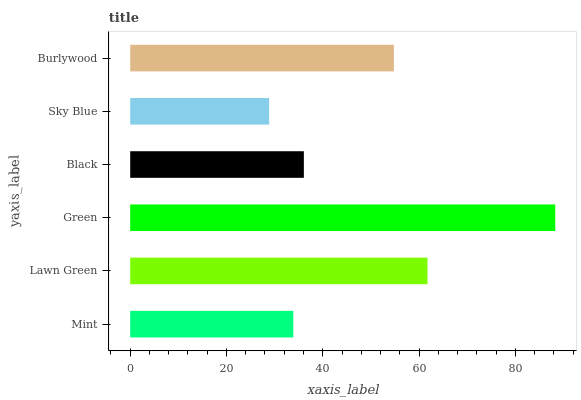Is Sky Blue the minimum?
Answer yes or no. Yes. Is Green the maximum?
Answer yes or no. Yes. Is Lawn Green the minimum?
Answer yes or no. No. Is Lawn Green the maximum?
Answer yes or no. No. Is Lawn Green greater than Mint?
Answer yes or no. Yes. Is Mint less than Lawn Green?
Answer yes or no. Yes. Is Mint greater than Lawn Green?
Answer yes or no. No. Is Lawn Green less than Mint?
Answer yes or no. No. Is Burlywood the high median?
Answer yes or no. Yes. Is Black the low median?
Answer yes or no. Yes. Is Mint the high median?
Answer yes or no. No. Is Mint the low median?
Answer yes or no. No. 